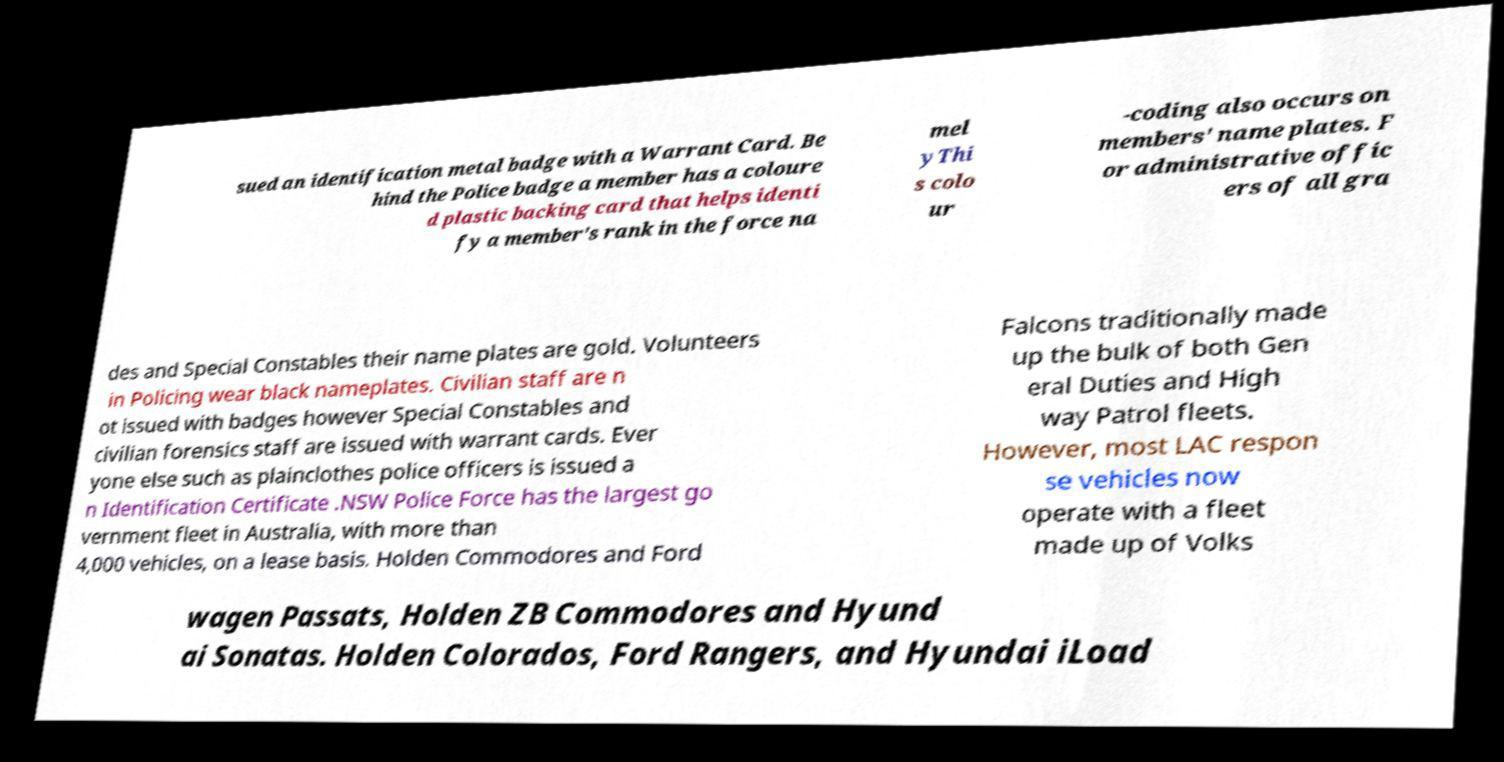Please read and relay the text visible in this image. What does it say? sued an identification metal badge with a Warrant Card. Be hind the Police badge a member has a coloure d plastic backing card that helps identi fy a member's rank in the force na mel yThi s colo ur -coding also occurs on members' name plates. F or administrative offic ers of all gra des and Special Constables their name plates are gold. Volunteers in Policing wear black nameplates. Civilian staff are n ot issued with badges however Special Constables and civilian forensics staff are issued with warrant cards. Ever yone else such as plainclothes police officers is issued a n Identification Certificate .NSW Police Force has the largest go vernment fleet in Australia, with more than 4,000 vehicles, on a lease basis. Holden Commodores and Ford Falcons traditionally made up the bulk of both Gen eral Duties and High way Patrol fleets. However, most LAC respon se vehicles now operate with a fleet made up of Volks wagen Passats, Holden ZB Commodores and Hyund ai Sonatas. Holden Colorados, Ford Rangers, and Hyundai iLoad 